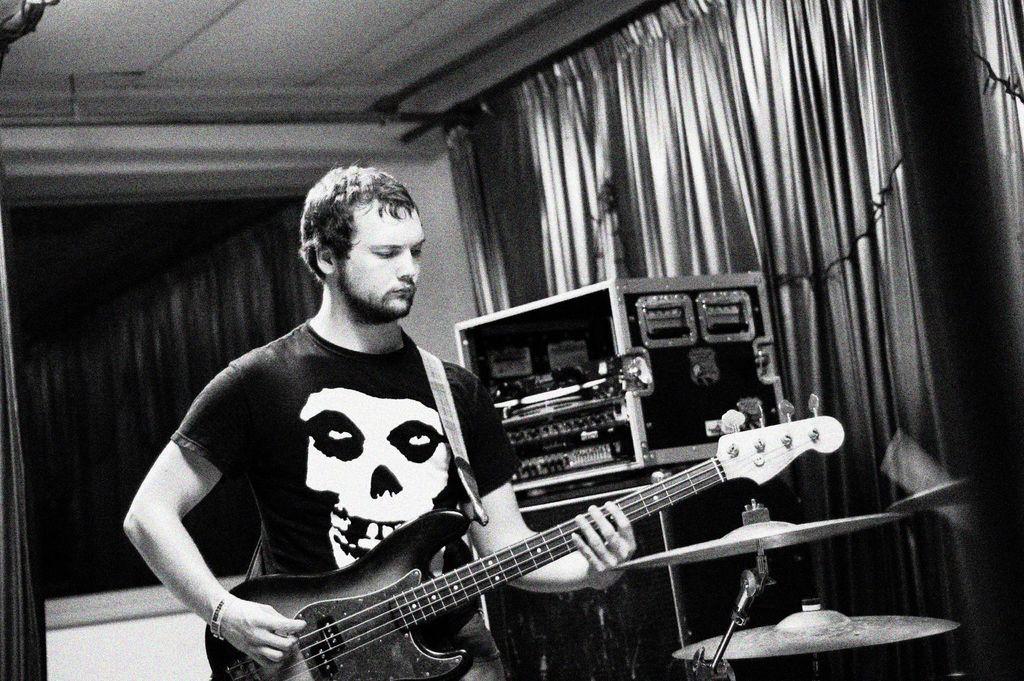Can you describe this image briefly? This is a black and white picture. On the background we can see curtains. Here we can see sound devices. We can see one man standing and playing guitar. These are cymbals, musical instrument. 